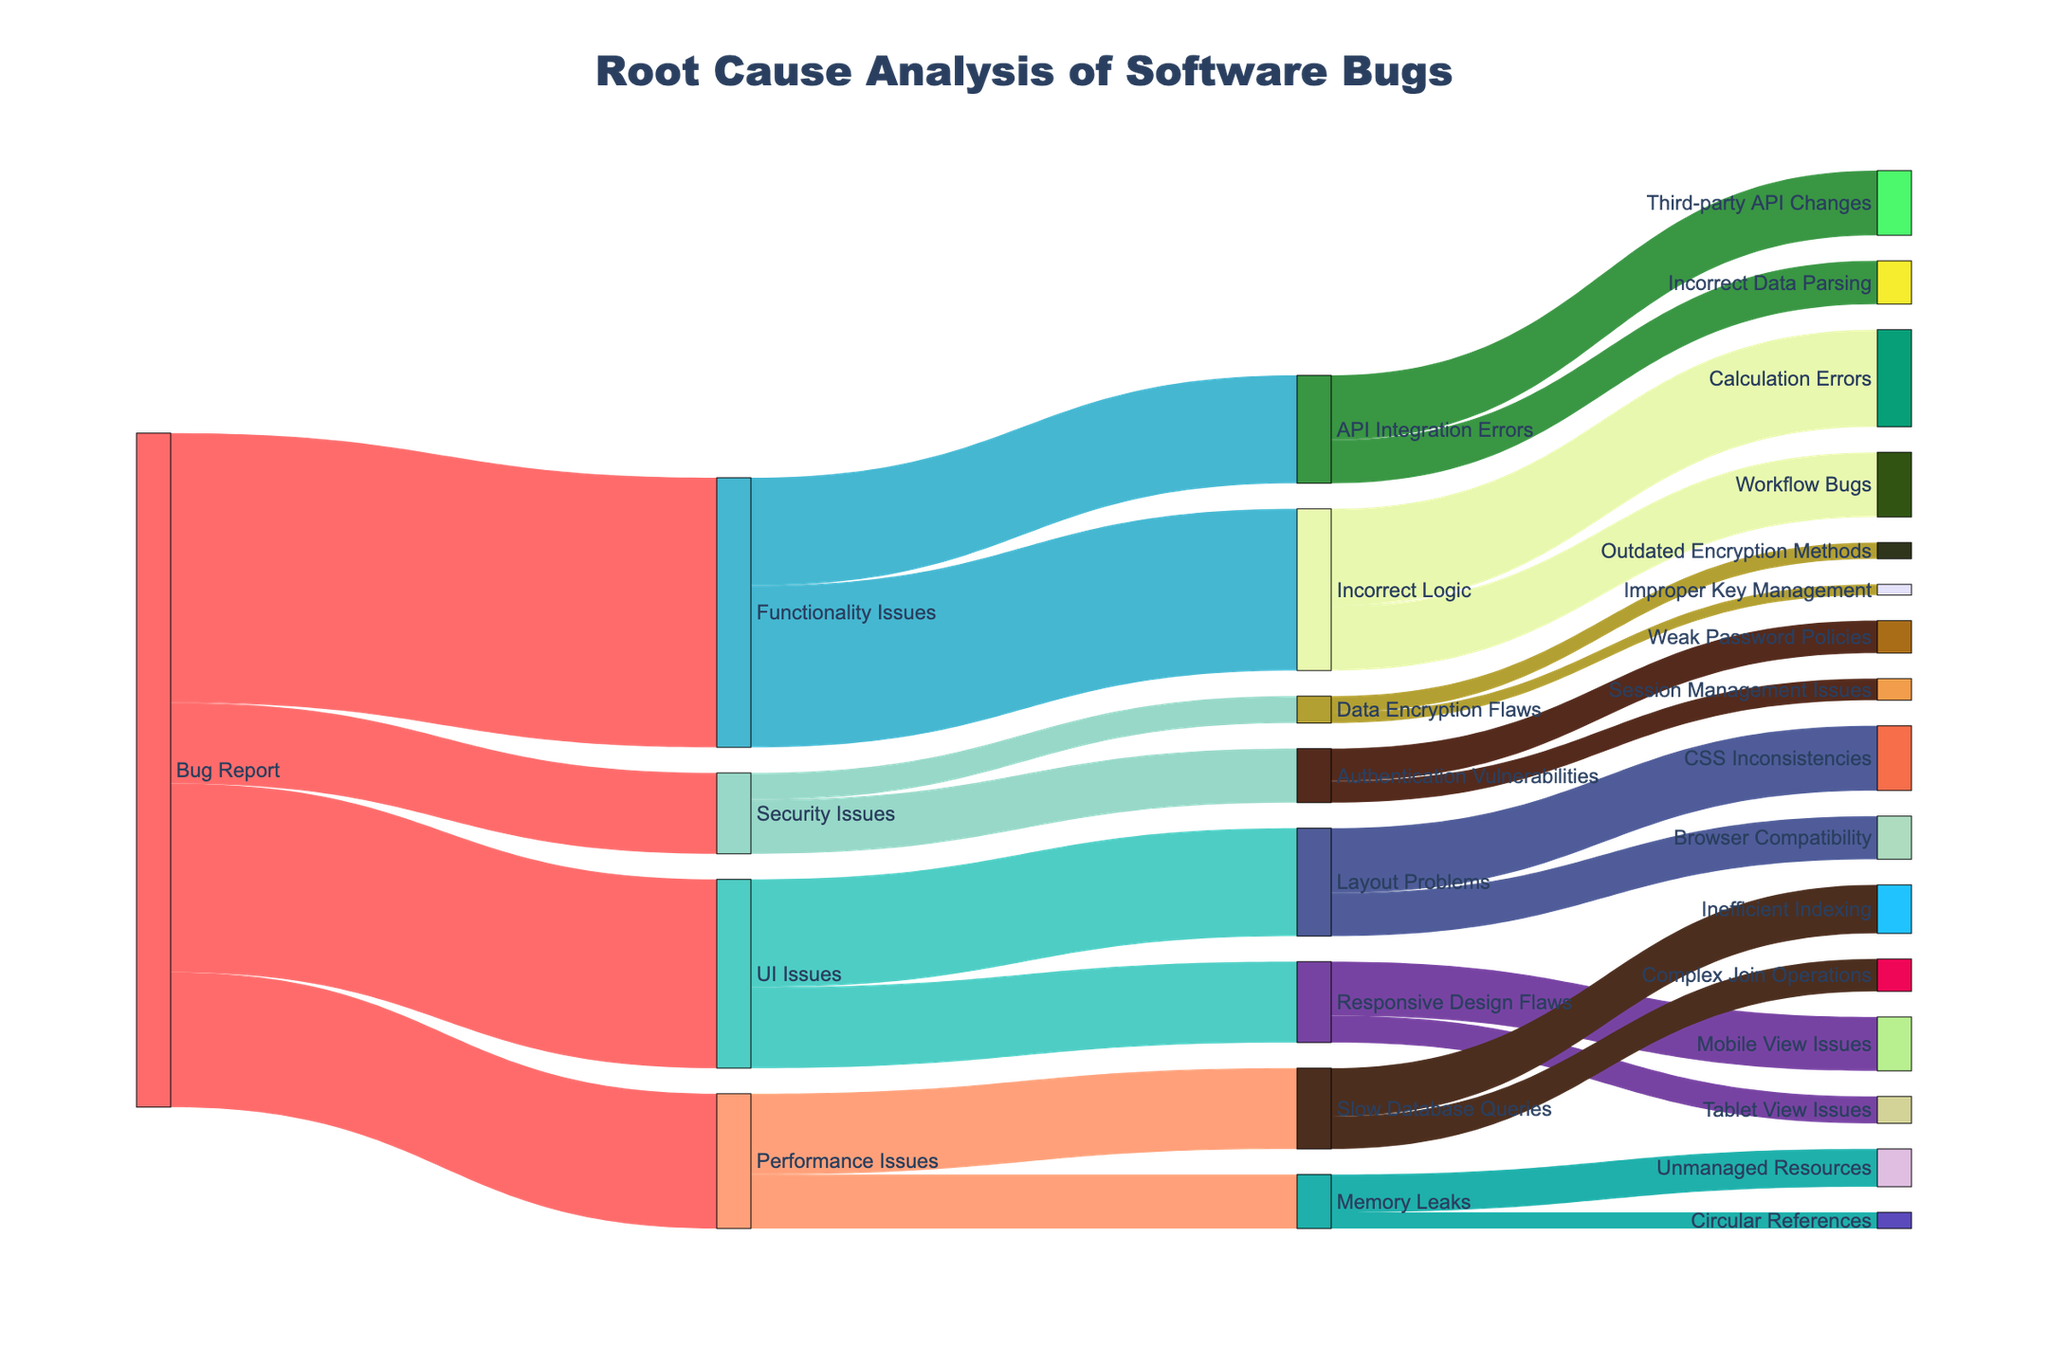what are the main categories of issues derived from bug reports? The Sankey Diagram shows the main categories of issues as the first level of targets directly connected to the "Bug Report" source. The categories are UI Issues, Functionality Issues, Performance Issues, and Security Issues.
Answer: UI Issues, Functionality Issues, Performance Issues, Security Issues How many total issues are categorized under UI Issues? To find the total UI Issues, sum the values of all targets connected to UI Issues: Layout Problems (20) + Responsive Design Flaws (15).
Answer: 35 What is the most common issue identified under Functionality Issues? Under Functionality Issues, the biggest flow is towards Incorrect Logic with a value of 30, which is larger than the value for API Integration Errors.
Answer: Incorrect Logic What number of issues are related to Performance Issues? Summing all the report counts connected to Performance Issues: Slow Database Queries (15) and Memory Leaks (10) provides the total.
Answer: 25 Which subcategory under Security Issues has the lowest count? The subcategories of Security Issues are Authentication Vulnerabilities (10) and Data Encryption Flaws (5). Within Data Encryption Flaws, Improper Key Management (2) is the lowest count.
Answer: Improper Key Management Compare the number of issues in UI Issues and Security Issues. Which has more? UI Issues have 35 issues, while Security Issues have 15. UI Issues have more.
Answer: UI Issues What are the two subcategories with the most issues originating from Functionality Issues? The subcategories of Functionality Issues are Incorrect Logic (30) and API Integration Errors (20). These are the two subcategories with the most issues.
Answer: Incorrect Logic, API Integration Errors Which specific category has the highest number of issues among all categories and subcategories? The specific category with the highest number is Functionality Issues with 50 issues. None of the subcategories exceed this value.
Answer: Functionality Issues How do the total numbers of issues related to Incorrect Logic and Authentication Vulnerabilities compare? Incorrect Logic has 30 issues, while Authentication Vulnerabilities has 10 issues. Incorrect Logic has significantly more issues.
Answer: Incorrect Logic Determine the total number of issues traced to root causes under Performance Issues. Combining the subcategories under Performance Issues, we sum Slow Database Queries (15) and Memory Leaks (10), further subdivided into Inefficient Indexing (9), Complex Join Operations (6), Unmanaged Resources (7), and Circular References (3). Summing these values gives 9 + 6 + 7 + 3 = 25.
Answer: 25 